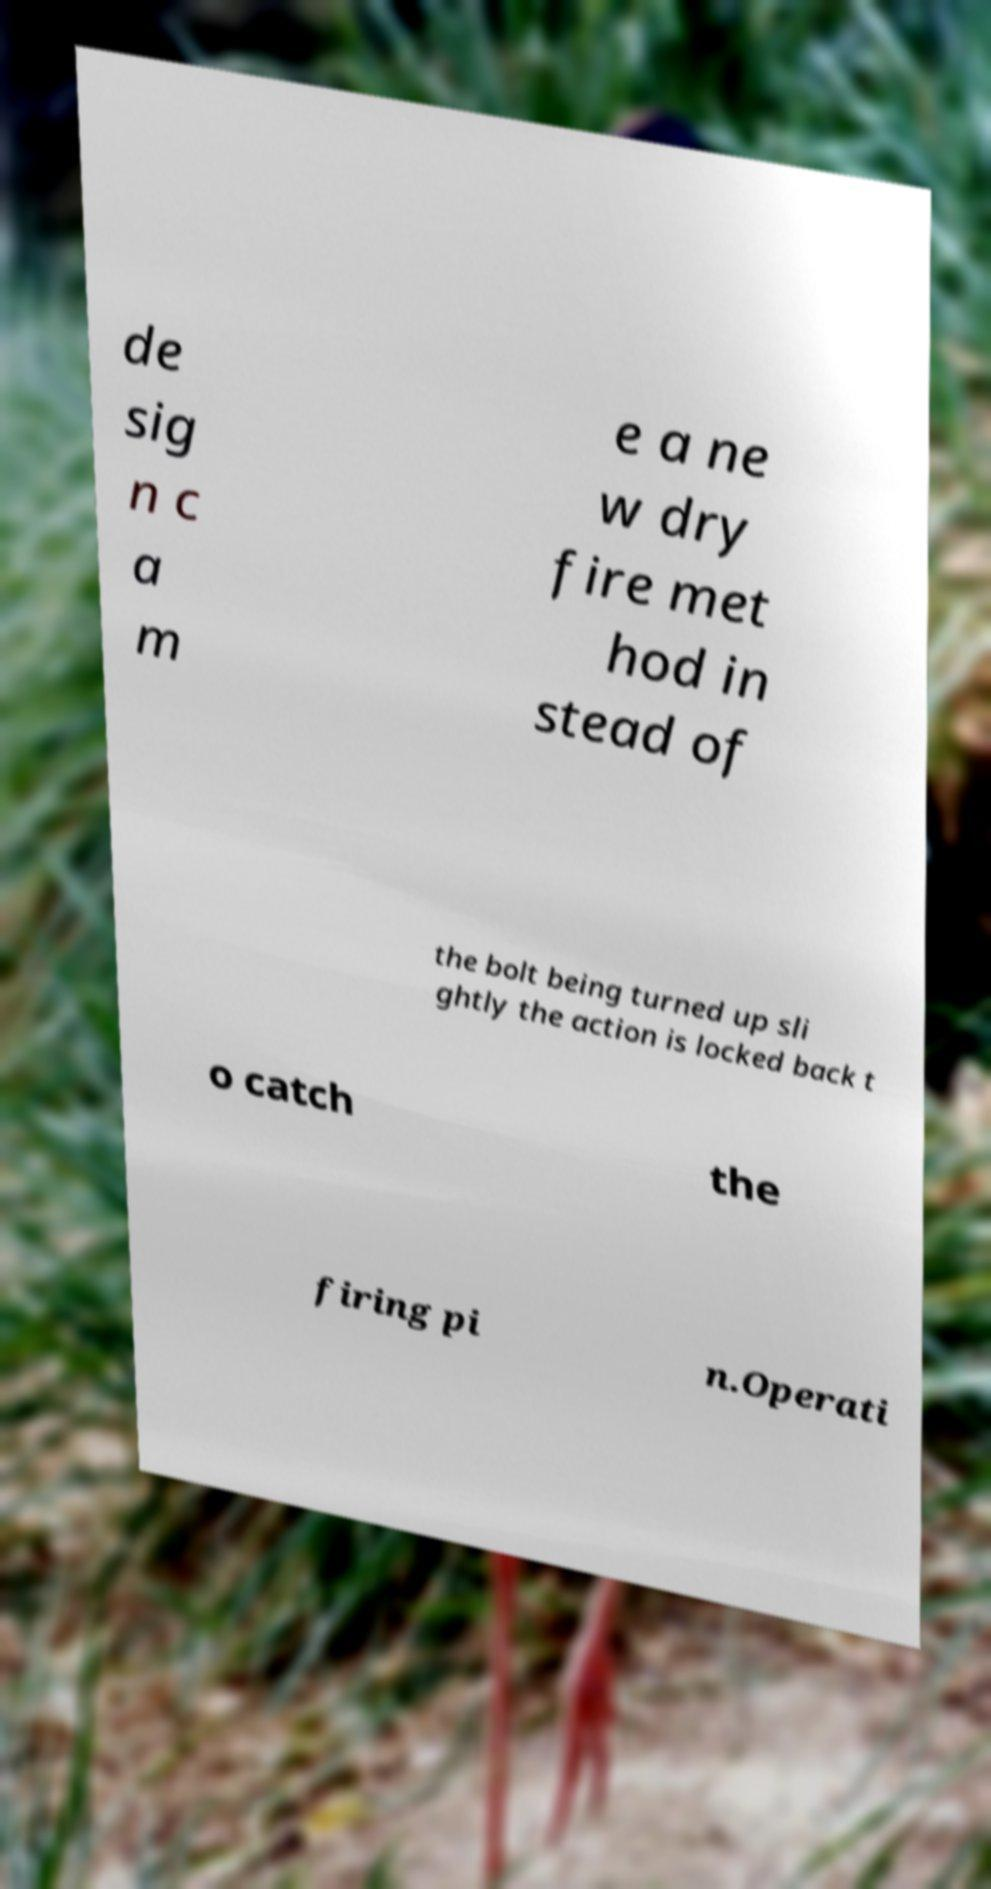I need the written content from this picture converted into text. Can you do that? de sig n c a m e a ne w dry fire met hod in stead of the bolt being turned up sli ghtly the action is locked back t o catch the firing pi n.Operati 